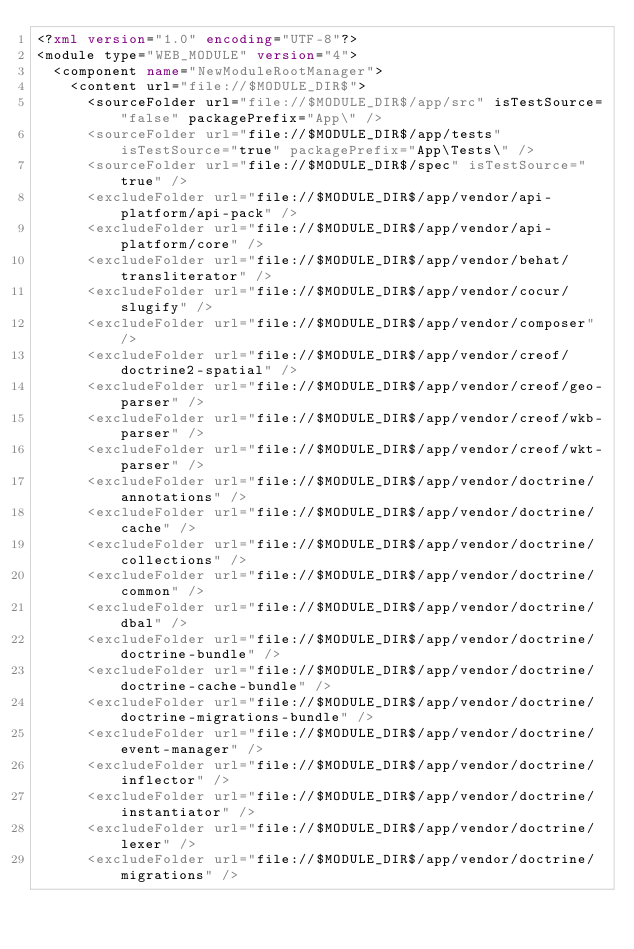Convert code to text. <code><loc_0><loc_0><loc_500><loc_500><_XML_><?xml version="1.0" encoding="UTF-8"?>
<module type="WEB_MODULE" version="4">
  <component name="NewModuleRootManager">
    <content url="file://$MODULE_DIR$">
      <sourceFolder url="file://$MODULE_DIR$/app/src" isTestSource="false" packagePrefix="App\" />
      <sourceFolder url="file://$MODULE_DIR$/app/tests" isTestSource="true" packagePrefix="App\Tests\" />
      <sourceFolder url="file://$MODULE_DIR$/spec" isTestSource="true" />
      <excludeFolder url="file://$MODULE_DIR$/app/vendor/api-platform/api-pack" />
      <excludeFolder url="file://$MODULE_DIR$/app/vendor/api-platform/core" />
      <excludeFolder url="file://$MODULE_DIR$/app/vendor/behat/transliterator" />
      <excludeFolder url="file://$MODULE_DIR$/app/vendor/cocur/slugify" />
      <excludeFolder url="file://$MODULE_DIR$/app/vendor/composer" />
      <excludeFolder url="file://$MODULE_DIR$/app/vendor/creof/doctrine2-spatial" />
      <excludeFolder url="file://$MODULE_DIR$/app/vendor/creof/geo-parser" />
      <excludeFolder url="file://$MODULE_DIR$/app/vendor/creof/wkb-parser" />
      <excludeFolder url="file://$MODULE_DIR$/app/vendor/creof/wkt-parser" />
      <excludeFolder url="file://$MODULE_DIR$/app/vendor/doctrine/annotations" />
      <excludeFolder url="file://$MODULE_DIR$/app/vendor/doctrine/cache" />
      <excludeFolder url="file://$MODULE_DIR$/app/vendor/doctrine/collections" />
      <excludeFolder url="file://$MODULE_DIR$/app/vendor/doctrine/common" />
      <excludeFolder url="file://$MODULE_DIR$/app/vendor/doctrine/dbal" />
      <excludeFolder url="file://$MODULE_DIR$/app/vendor/doctrine/doctrine-bundle" />
      <excludeFolder url="file://$MODULE_DIR$/app/vendor/doctrine/doctrine-cache-bundle" />
      <excludeFolder url="file://$MODULE_DIR$/app/vendor/doctrine/doctrine-migrations-bundle" />
      <excludeFolder url="file://$MODULE_DIR$/app/vendor/doctrine/event-manager" />
      <excludeFolder url="file://$MODULE_DIR$/app/vendor/doctrine/inflector" />
      <excludeFolder url="file://$MODULE_DIR$/app/vendor/doctrine/instantiator" />
      <excludeFolder url="file://$MODULE_DIR$/app/vendor/doctrine/lexer" />
      <excludeFolder url="file://$MODULE_DIR$/app/vendor/doctrine/migrations" /></code> 